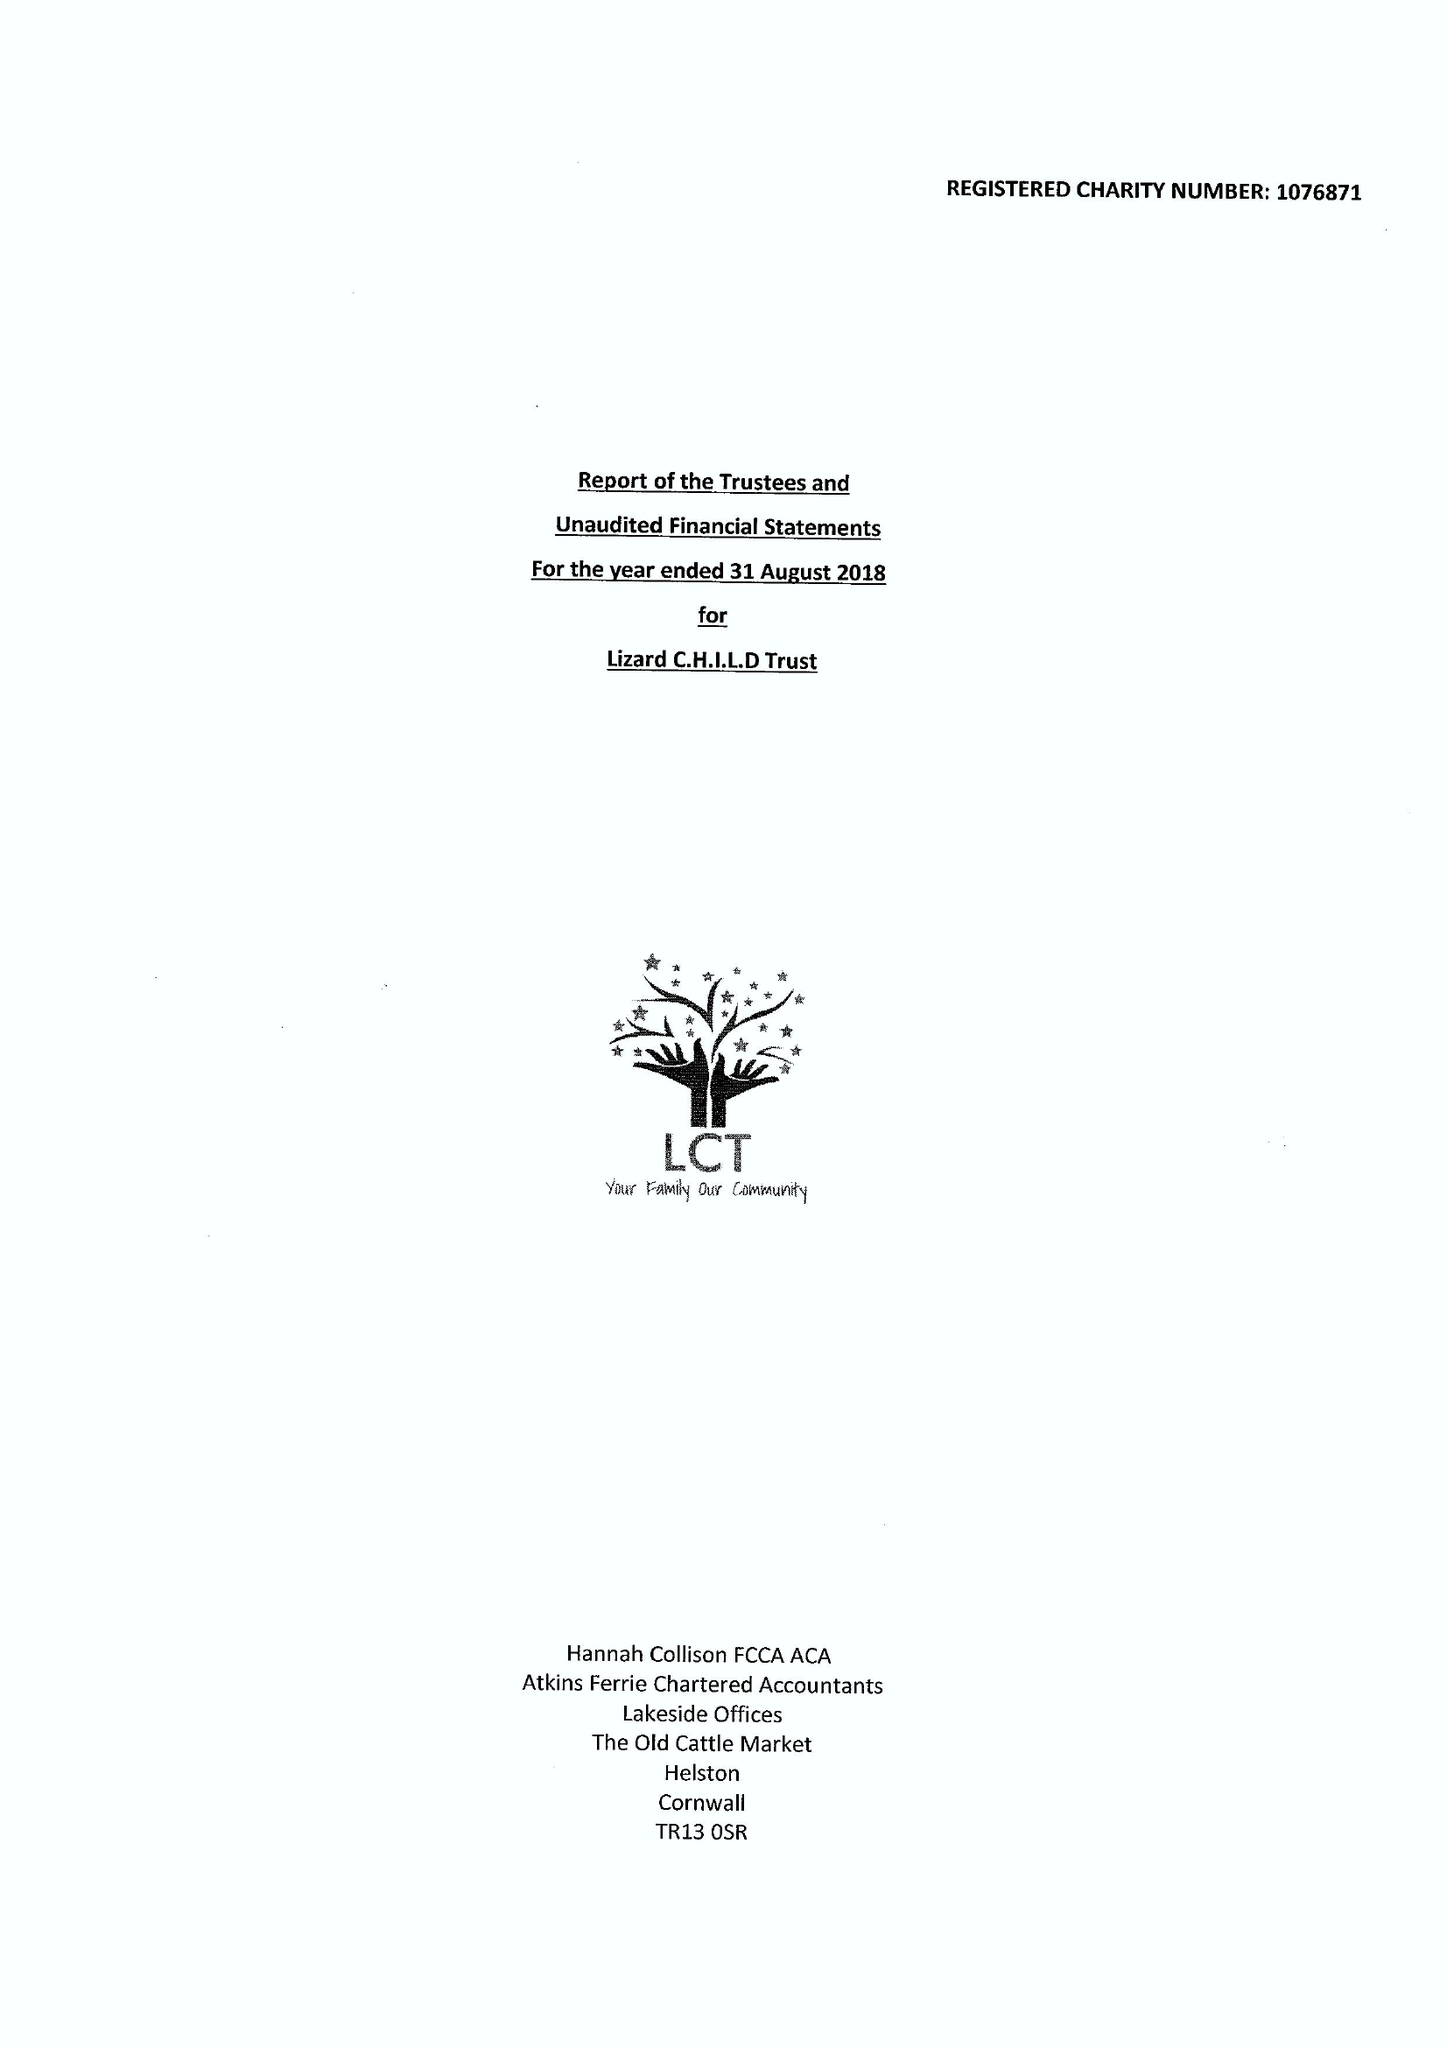What is the value for the address__post_town?
Answer the question using a single word or phrase. HELSTON 